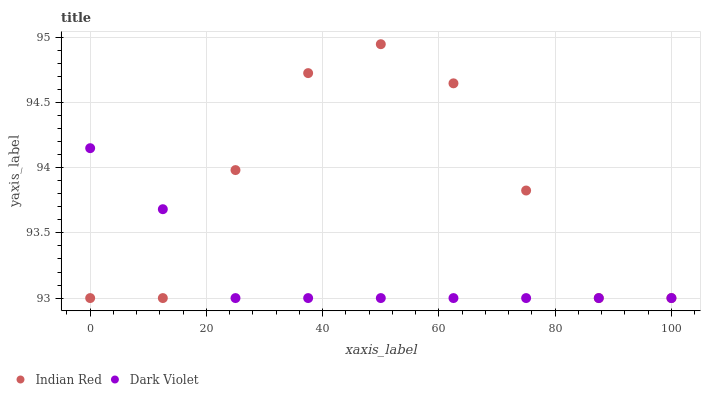Does Dark Violet have the minimum area under the curve?
Answer yes or no. Yes. Does Indian Red have the maximum area under the curve?
Answer yes or no. Yes. Does Indian Red have the minimum area under the curve?
Answer yes or no. No. Is Dark Violet the smoothest?
Answer yes or no. Yes. Is Indian Red the roughest?
Answer yes or no. Yes. Is Indian Red the smoothest?
Answer yes or no. No. Does Dark Violet have the lowest value?
Answer yes or no. Yes. Does Indian Red have the highest value?
Answer yes or no. Yes. Does Indian Red intersect Dark Violet?
Answer yes or no. Yes. Is Indian Red less than Dark Violet?
Answer yes or no. No. Is Indian Red greater than Dark Violet?
Answer yes or no. No. 